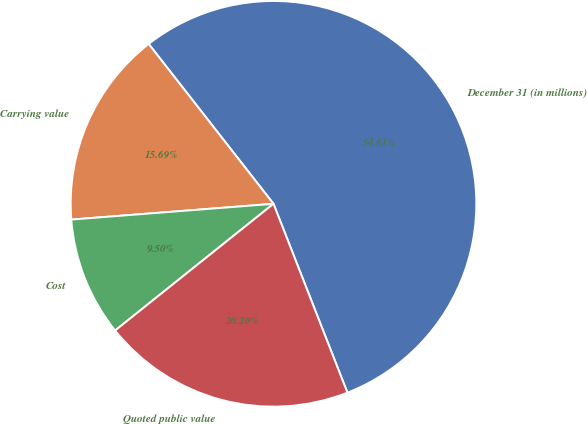Convert chart. <chart><loc_0><loc_0><loc_500><loc_500><pie_chart><fcel>December 31 (in millions)<fcel>Carrying value<fcel>Cost<fcel>Quoted public value<nl><fcel>54.61%<fcel>15.69%<fcel>9.5%<fcel>20.2%<nl></chart> 